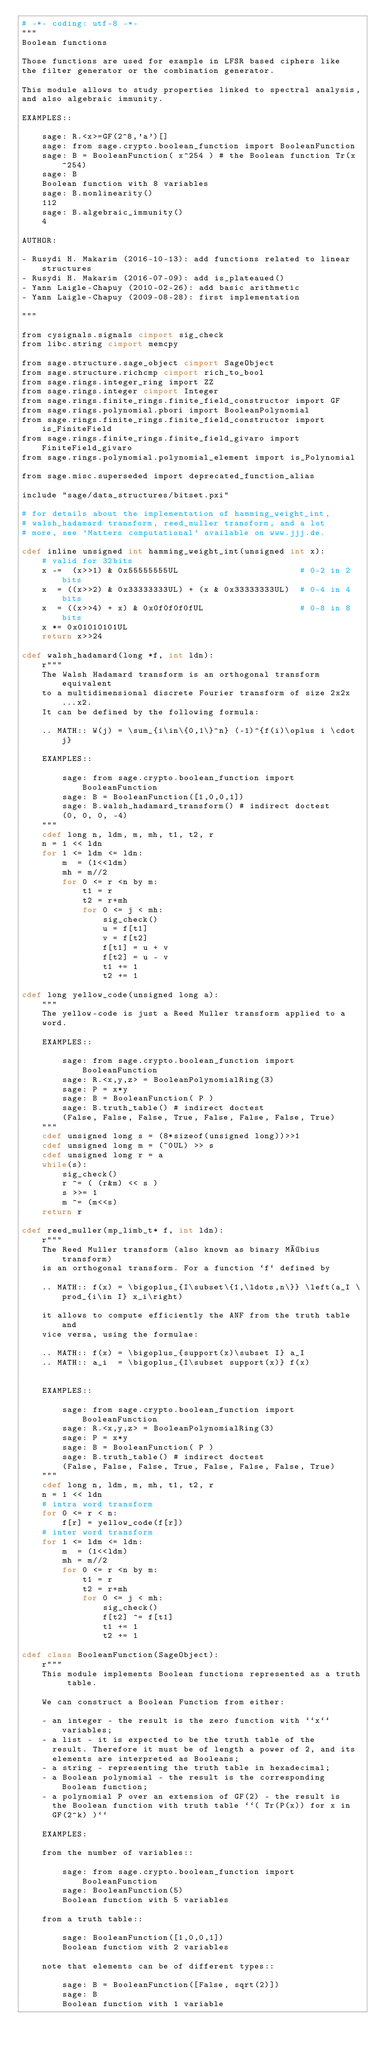<code> <loc_0><loc_0><loc_500><loc_500><_Cython_># -*- coding: utf-8 -*-
"""
Boolean functions

Those functions are used for example in LFSR based ciphers like
the filter generator or the combination generator.

This module allows to study properties linked to spectral analysis,
and also algebraic immunity.

EXAMPLES::

    sage: R.<x>=GF(2^8,'a')[]
    sage: from sage.crypto.boolean_function import BooleanFunction
    sage: B = BooleanFunction( x^254 ) # the Boolean function Tr(x^254)
    sage: B
    Boolean function with 8 variables
    sage: B.nonlinearity()
    112
    sage: B.algebraic_immunity()
    4

AUTHOR:

- Rusydi H. Makarim (2016-10-13): add functions related to linear structures
- Rusydi H. Makarim (2016-07-09): add is_plateaued()
- Yann Laigle-Chapuy (2010-02-26): add basic arithmetic
- Yann Laigle-Chapuy (2009-08-28): first implementation

"""

from cysignals.signals cimport sig_check
from libc.string cimport memcpy

from sage.structure.sage_object cimport SageObject
from sage.structure.richcmp cimport rich_to_bool
from sage.rings.integer_ring import ZZ
from sage.rings.integer cimport Integer
from sage.rings.finite_rings.finite_field_constructor import GF
from sage.rings.polynomial.pbori import BooleanPolynomial
from sage.rings.finite_rings.finite_field_constructor import is_FiniteField
from sage.rings.finite_rings.finite_field_givaro import FiniteField_givaro
from sage.rings.polynomial.polynomial_element import is_Polynomial

from sage.misc.superseded import deprecated_function_alias

include "sage/data_structures/bitset.pxi"

# for details about the implementation of hamming_weight_int,
# walsh_hadamard transform, reed_muller transform, and a lot
# more, see 'Matters computational' available on www.jjj.de.

cdef inline unsigned int hamming_weight_int(unsigned int x):
    # valid for 32bits
    x -=  (x>>1) & 0x55555555UL                        # 0-2 in 2 bits
    x  = ((x>>2) & 0x33333333UL) + (x & 0x33333333UL)  # 0-4 in 4 bits
    x  = ((x>>4) + x) & 0x0f0f0f0fUL                   # 0-8 in 8 bits
    x *= 0x01010101UL
    return x>>24

cdef walsh_hadamard(long *f, int ldn):
    r"""
    The Walsh Hadamard transform is an orthogonal transform equivalent
    to a multidimensional discrete Fourier transform of size 2x2x...x2.
    It can be defined by the following formula:

    .. MATH:: W(j) = \sum_{i\in\{0,1\}^n} (-1)^{f(i)\oplus i \cdot j}

    EXAMPLES::

        sage: from sage.crypto.boolean_function import BooleanFunction
        sage: B = BooleanFunction([1,0,0,1])
        sage: B.walsh_hadamard_transform() # indirect doctest
        (0, 0, 0, -4)
    """
    cdef long n, ldm, m, mh, t1, t2, r
    n = 1 << ldn
    for 1 <= ldm <= ldn:
        m  = (1<<ldm)
        mh = m//2
        for 0 <= r <n by m:
            t1 = r
            t2 = r+mh
            for 0 <= j < mh:
                sig_check()
                u = f[t1]
                v = f[t2]
                f[t1] = u + v
                f[t2] = u - v
                t1 += 1
                t2 += 1

cdef long yellow_code(unsigned long a):
    """
    The yellow-code is just a Reed Muller transform applied to a
    word.

    EXAMPLES::

        sage: from sage.crypto.boolean_function import BooleanFunction
        sage: R.<x,y,z> = BooleanPolynomialRing(3)
        sage: P = x*y
        sage: B = BooleanFunction( P )
        sage: B.truth_table() # indirect doctest
        (False, False, False, True, False, False, False, True)
    """
    cdef unsigned long s = (8*sizeof(unsigned long))>>1
    cdef unsigned long m = (~0UL) >> s
    cdef unsigned long r = a
    while(s):
        sig_check()
        r ^= ( (r&m) << s )
        s >>= 1
        m ^= (m<<s)
    return r

cdef reed_muller(mp_limb_t* f, int ldn):
    r"""
    The Reed Muller transform (also known as binary Möbius transform)
    is an orthogonal transform. For a function `f` defined by

    .. MATH:: f(x) = \bigoplus_{I\subset\{1,\ldots,n\}} \left(a_I \prod_{i\in I} x_i\right)

    it allows to compute efficiently the ANF from the truth table and
    vice versa, using the formulae:

    .. MATH:: f(x) = \bigoplus_{support(x)\subset I} a_I
    .. MATH:: a_i  = \bigoplus_{I\subset support(x)} f(x)


    EXAMPLES::

        sage: from sage.crypto.boolean_function import BooleanFunction
        sage: R.<x,y,z> = BooleanPolynomialRing(3)
        sage: P = x*y
        sage: B = BooleanFunction( P )
        sage: B.truth_table() # indirect doctest
        (False, False, False, True, False, False, False, True)
    """
    cdef long n, ldm, m, mh, t1, t2, r
    n = 1 << ldn
    # intra word transform
    for 0 <= r < n:
        f[r] = yellow_code(f[r])
    # inter word transform
    for 1 <= ldm <= ldn:
        m  = (1<<ldm)
        mh = m//2
        for 0 <= r <n by m:
            t1 = r
            t2 = r+mh
            for 0 <= j < mh:
                sig_check()
                f[t2] ^= f[t1]
                t1 += 1
                t2 += 1

cdef class BooleanFunction(SageObject):
    r"""
    This module implements Boolean functions represented as a truth table.

    We can construct a Boolean Function from either:

    - an integer - the result is the zero function with ``x`` variables;
    - a list - it is expected to be the truth table of the
      result. Therefore it must be of length a power of 2, and its
      elements are interpreted as Booleans;
    - a string - representing the truth table in hexadecimal;
    - a Boolean polynomial - the result is the corresponding Boolean function;
    - a polynomial P over an extension of GF(2) - the result is
      the Boolean function with truth table ``( Tr(P(x)) for x in
      GF(2^k) )``

    EXAMPLES:

    from the number of variables::

        sage: from sage.crypto.boolean_function import BooleanFunction
        sage: BooleanFunction(5)
        Boolean function with 5 variables

    from a truth table::

        sage: BooleanFunction([1,0,0,1])
        Boolean function with 2 variables

    note that elements can be of different types::

        sage: B = BooleanFunction([False, sqrt(2)])
        sage: B
        Boolean function with 1 variable</code> 